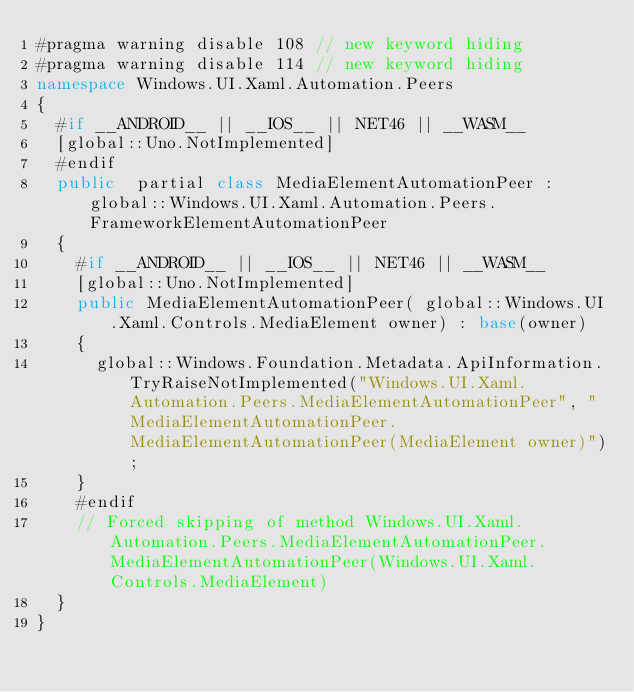<code> <loc_0><loc_0><loc_500><loc_500><_C#_>#pragma warning disable 108 // new keyword hiding
#pragma warning disable 114 // new keyword hiding
namespace Windows.UI.Xaml.Automation.Peers
{
	#if __ANDROID__ || __IOS__ || NET46 || __WASM__
	[global::Uno.NotImplemented]
	#endif
	public  partial class MediaElementAutomationPeer : global::Windows.UI.Xaml.Automation.Peers.FrameworkElementAutomationPeer
	{
		#if __ANDROID__ || __IOS__ || NET46 || __WASM__
		[global::Uno.NotImplemented]
		public MediaElementAutomationPeer( global::Windows.UI.Xaml.Controls.MediaElement owner) : base(owner)
		{
			global::Windows.Foundation.Metadata.ApiInformation.TryRaiseNotImplemented("Windows.UI.Xaml.Automation.Peers.MediaElementAutomationPeer", "MediaElementAutomationPeer.MediaElementAutomationPeer(MediaElement owner)");
		}
		#endif
		// Forced skipping of method Windows.UI.Xaml.Automation.Peers.MediaElementAutomationPeer.MediaElementAutomationPeer(Windows.UI.Xaml.Controls.MediaElement)
	}
}
</code> 